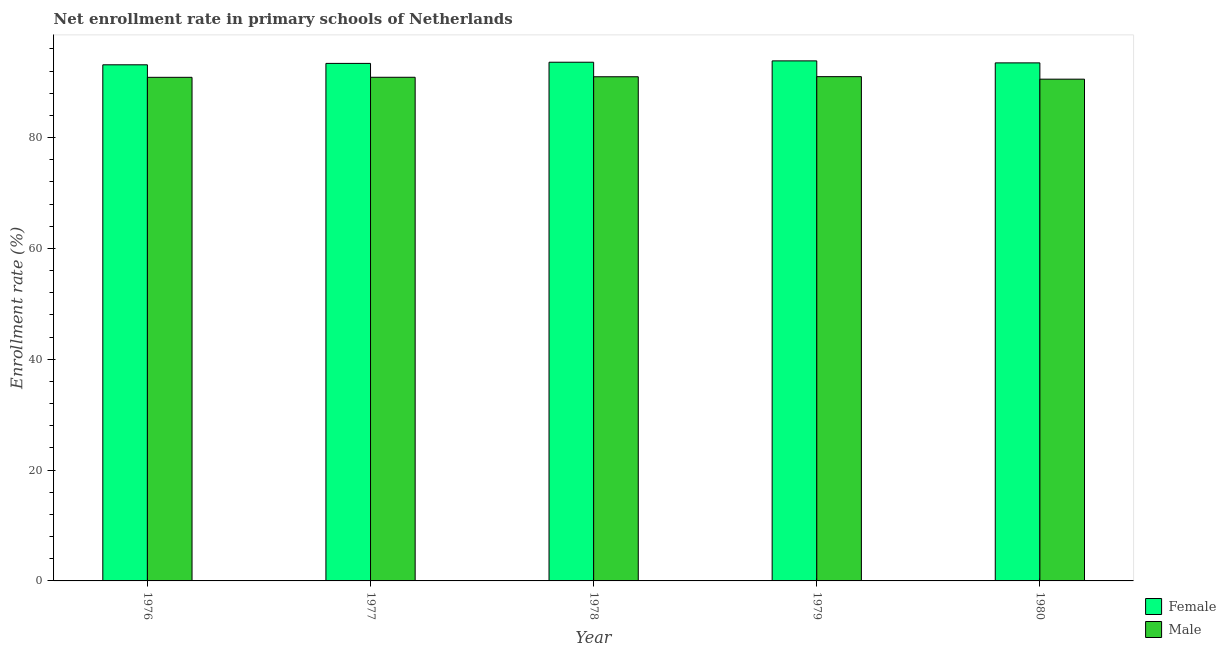How many groups of bars are there?
Ensure brevity in your answer.  5. Are the number of bars on each tick of the X-axis equal?
Make the answer very short. Yes. What is the label of the 1st group of bars from the left?
Your response must be concise. 1976. What is the enrollment rate of male students in 1977?
Your answer should be compact. 90.89. Across all years, what is the maximum enrollment rate of male students?
Your answer should be very brief. 91. Across all years, what is the minimum enrollment rate of female students?
Offer a terse response. 93.14. In which year was the enrollment rate of male students maximum?
Ensure brevity in your answer.  1979. In which year was the enrollment rate of female students minimum?
Ensure brevity in your answer.  1976. What is the total enrollment rate of male students in the graph?
Provide a succinct answer. 454.31. What is the difference between the enrollment rate of female students in 1978 and that in 1980?
Ensure brevity in your answer.  0.12. What is the difference between the enrollment rate of male students in 1978 and the enrollment rate of female students in 1979?
Your response must be concise. -0.02. What is the average enrollment rate of male students per year?
Keep it short and to the point. 90.86. In the year 1979, what is the difference between the enrollment rate of female students and enrollment rate of male students?
Offer a very short reply. 0. In how many years, is the enrollment rate of female students greater than 32 %?
Your answer should be compact. 5. What is the ratio of the enrollment rate of male students in 1978 to that in 1979?
Your answer should be compact. 1. Is the enrollment rate of male students in 1978 less than that in 1979?
Give a very brief answer. Yes. Is the difference between the enrollment rate of female students in 1977 and 1978 greater than the difference between the enrollment rate of male students in 1977 and 1978?
Your answer should be compact. No. What is the difference between the highest and the second highest enrollment rate of male students?
Offer a very short reply. 0.02. What is the difference between the highest and the lowest enrollment rate of female students?
Provide a short and direct response. 0.71. Is the sum of the enrollment rate of male students in 1976 and 1980 greater than the maximum enrollment rate of female students across all years?
Your answer should be compact. Yes. Are all the bars in the graph horizontal?
Provide a short and direct response. No. What is the difference between two consecutive major ticks on the Y-axis?
Give a very brief answer. 20. Does the graph contain any zero values?
Keep it short and to the point. No. Does the graph contain grids?
Your answer should be compact. No. How are the legend labels stacked?
Provide a succinct answer. Vertical. What is the title of the graph?
Provide a short and direct response. Net enrollment rate in primary schools of Netherlands. What is the label or title of the X-axis?
Keep it short and to the point. Year. What is the label or title of the Y-axis?
Keep it short and to the point. Enrollment rate (%). What is the Enrollment rate (%) in Female in 1976?
Give a very brief answer. 93.14. What is the Enrollment rate (%) in Male in 1976?
Offer a terse response. 90.88. What is the Enrollment rate (%) of Female in 1977?
Provide a short and direct response. 93.39. What is the Enrollment rate (%) in Male in 1977?
Give a very brief answer. 90.89. What is the Enrollment rate (%) in Female in 1978?
Your answer should be very brief. 93.61. What is the Enrollment rate (%) of Male in 1978?
Offer a terse response. 90.98. What is the Enrollment rate (%) in Female in 1979?
Your response must be concise. 93.85. What is the Enrollment rate (%) of Male in 1979?
Your response must be concise. 91. What is the Enrollment rate (%) in Female in 1980?
Offer a terse response. 93.49. What is the Enrollment rate (%) of Male in 1980?
Offer a terse response. 90.55. Across all years, what is the maximum Enrollment rate (%) in Female?
Ensure brevity in your answer.  93.85. Across all years, what is the maximum Enrollment rate (%) of Male?
Your answer should be compact. 91. Across all years, what is the minimum Enrollment rate (%) in Female?
Offer a terse response. 93.14. Across all years, what is the minimum Enrollment rate (%) in Male?
Offer a terse response. 90.55. What is the total Enrollment rate (%) in Female in the graph?
Keep it short and to the point. 467.48. What is the total Enrollment rate (%) in Male in the graph?
Give a very brief answer. 454.31. What is the difference between the Enrollment rate (%) of Female in 1976 and that in 1977?
Make the answer very short. -0.26. What is the difference between the Enrollment rate (%) in Male in 1976 and that in 1977?
Offer a terse response. -0.01. What is the difference between the Enrollment rate (%) of Female in 1976 and that in 1978?
Offer a very short reply. -0.47. What is the difference between the Enrollment rate (%) in Male in 1976 and that in 1978?
Your answer should be compact. -0.1. What is the difference between the Enrollment rate (%) in Female in 1976 and that in 1979?
Give a very brief answer. -0.71. What is the difference between the Enrollment rate (%) of Male in 1976 and that in 1979?
Ensure brevity in your answer.  -0.12. What is the difference between the Enrollment rate (%) of Female in 1976 and that in 1980?
Ensure brevity in your answer.  -0.35. What is the difference between the Enrollment rate (%) in Male in 1976 and that in 1980?
Make the answer very short. 0.33. What is the difference between the Enrollment rate (%) of Female in 1977 and that in 1978?
Keep it short and to the point. -0.21. What is the difference between the Enrollment rate (%) of Male in 1977 and that in 1978?
Your answer should be very brief. -0.09. What is the difference between the Enrollment rate (%) in Female in 1977 and that in 1979?
Keep it short and to the point. -0.45. What is the difference between the Enrollment rate (%) of Male in 1977 and that in 1979?
Keep it short and to the point. -0.11. What is the difference between the Enrollment rate (%) of Female in 1977 and that in 1980?
Give a very brief answer. -0.09. What is the difference between the Enrollment rate (%) of Male in 1977 and that in 1980?
Your response must be concise. 0.34. What is the difference between the Enrollment rate (%) of Female in 1978 and that in 1979?
Your answer should be compact. -0.24. What is the difference between the Enrollment rate (%) of Male in 1978 and that in 1979?
Provide a succinct answer. -0.02. What is the difference between the Enrollment rate (%) of Female in 1978 and that in 1980?
Make the answer very short. 0.12. What is the difference between the Enrollment rate (%) of Male in 1978 and that in 1980?
Ensure brevity in your answer.  0.44. What is the difference between the Enrollment rate (%) in Female in 1979 and that in 1980?
Keep it short and to the point. 0.36. What is the difference between the Enrollment rate (%) of Male in 1979 and that in 1980?
Offer a terse response. 0.45. What is the difference between the Enrollment rate (%) of Female in 1976 and the Enrollment rate (%) of Male in 1977?
Provide a short and direct response. 2.25. What is the difference between the Enrollment rate (%) in Female in 1976 and the Enrollment rate (%) in Male in 1978?
Provide a succinct answer. 2.16. What is the difference between the Enrollment rate (%) of Female in 1976 and the Enrollment rate (%) of Male in 1979?
Give a very brief answer. 2.14. What is the difference between the Enrollment rate (%) of Female in 1976 and the Enrollment rate (%) of Male in 1980?
Provide a succinct answer. 2.59. What is the difference between the Enrollment rate (%) in Female in 1977 and the Enrollment rate (%) in Male in 1978?
Provide a short and direct response. 2.41. What is the difference between the Enrollment rate (%) of Female in 1977 and the Enrollment rate (%) of Male in 1979?
Offer a terse response. 2.39. What is the difference between the Enrollment rate (%) of Female in 1977 and the Enrollment rate (%) of Male in 1980?
Offer a terse response. 2.85. What is the difference between the Enrollment rate (%) of Female in 1978 and the Enrollment rate (%) of Male in 1979?
Offer a very short reply. 2.6. What is the difference between the Enrollment rate (%) in Female in 1978 and the Enrollment rate (%) in Male in 1980?
Give a very brief answer. 3.06. What is the difference between the Enrollment rate (%) of Female in 1979 and the Enrollment rate (%) of Male in 1980?
Your answer should be very brief. 3.3. What is the average Enrollment rate (%) of Female per year?
Give a very brief answer. 93.5. What is the average Enrollment rate (%) in Male per year?
Keep it short and to the point. 90.86. In the year 1976, what is the difference between the Enrollment rate (%) in Female and Enrollment rate (%) in Male?
Ensure brevity in your answer.  2.26. In the year 1977, what is the difference between the Enrollment rate (%) in Female and Enrollment rate (%) in Male?
Your answer should be compact. 2.51. In the year 1978, what is the difference between the Enrollment rate (%) in Female and Enrollment rate (%) in Male?
Offer a very short reply. 2.62. In the year 1979, what is the difference between the Enrollment rate (%) in Female and Enrollment rate (%) in Male?
Ensure brevity in your answer.  2.85. In the year 1980, what is the difference between the Enrollment rate (%) of Female and Enrollment rate (%) of Male?
Offer a terse response. 2.94. What is the ratio of the Enrollment rate (%) in Female in 1976 to that in 1977?
Offer a terse response. 1. What is the ratio of the Enrollment rate (%) in Male in 1976 to that in 1977?
Ensure brevity in your answer.  1. What is the ratio of the Enrollment rate (%) of Female in 1976 to that in 1978?
Provide a short and direct response. 0.99. What is the ratio of the Enrollment rate (%) in Male in 1976 to that in 1979?
Make the answer very short. 1. What is the ratio of the Enrollment rate (%) of Female in 1976 to that in 1980?
Provide a succinct answer. 1. What is the ratio of the Enrollment rate (%) in Male in 1977 to that in 1979?
Provide a succinct answer. 1. What is the ratio of the Enrollment rate (%) of Male in 1978 to that in 1979?
Ensure brevity in your answer.  1. What is the ratio of the Enrollment rate (%) of Female in 1978 to that in 1980?
Your response must be concise. 1. What is the ratio of the Enrollment rate (%) of Female in 1979 to that in 1980?
Your answer should be very brief. 1. What is the ratio of the Enrollment rate (%) in Male in 1979 to that in 1980?
Provide a succinct answer. 1. What is the difference between the highest and the second highest Enrollment rate (%) of Female?
Make the answer very short. 0.24. What is the difference between the highest and the second highest Enrollment rate (%) in Male?
Your answer should be compact. 0.02. What is the difference between the highest and the lowest Enrollment rate (%) in Female?
Ensure brevity in your answer.  0.71. What is the difference between the highest and the lowest Enrollment rate (%) in Male?
Your answer should be very brief. 0.45. 